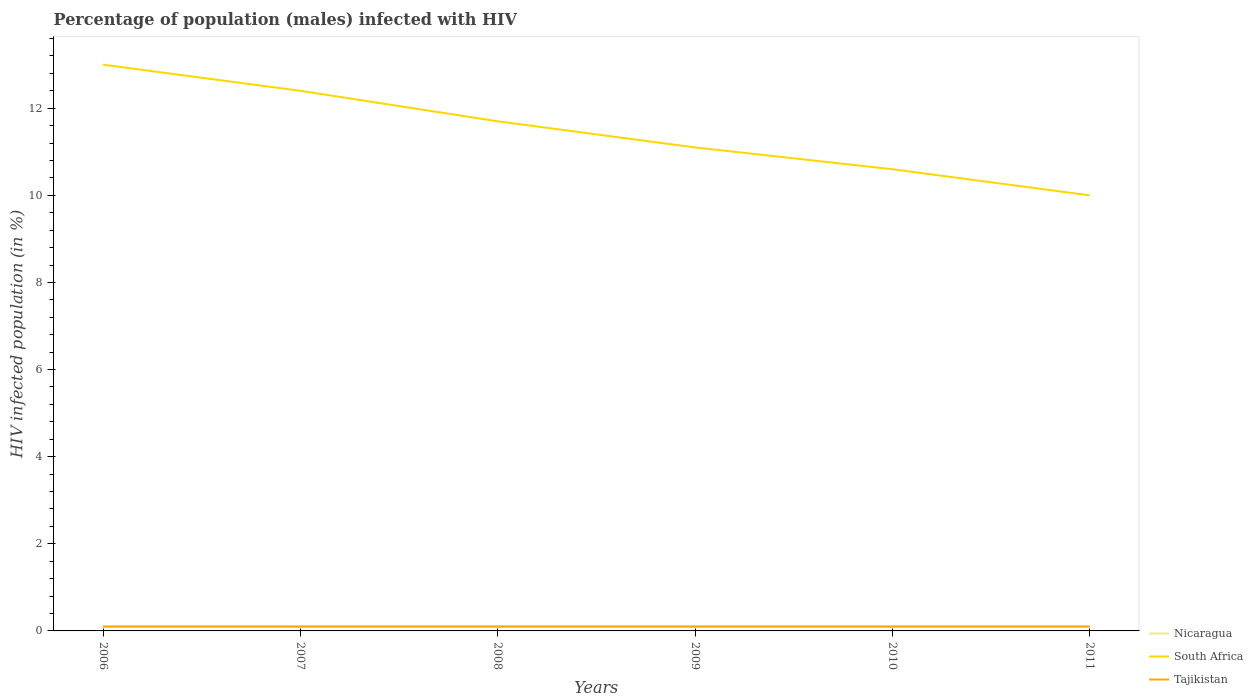How many different coloured lines are there?
Give a very brief answer. 3. In which year was the percentage of HIV infected male population in Tajikistan maximum?
Make the answer very short. 2006. What is the total percentage of HIV infected male population in South Africa in the graph?
Offer a terse response. 0.5. What is the difference between the highest and the lowest percentage of HIV infected male population in Tajikistan?
Provide a short and direct response. 6. Is the percentage of HIV infected male population in South Africa strictly greater than the percentage of HIV infected male population in Nicaragua over the years?
Provide a short and direct response. No. How many lines are there?
Ensure brevity in your answer.  3. How many years are there in the graph?
Make the answer very short. 6. Are the values on the major ticks of Y-axis written in scientific E-notation?
Ensure brevity in your answer.  No. Does the graph contain grids?
Make the answer very short. No. How are the legend labels stacked?
Offer a very short reply. Vertical. What is the title of the graph?
Ensure brevity in your answer.  Percentage of population (males) infected with HIV. What is the label or title of the X-axis?
Your answer should be compact. Years. What is the label or title of the Y-axis?
Make the answer very short. HIV infected population (in %). What is the HIV infected population (in %) in Nicaragua in 2006?
Keep it short and to the point. 0.1. What is the HIV infected population (in %) of South Africa in 2006?
Provide a short and direct response. 13. What is the HIV infected population (in %) of Tajikistan in 2006?
Make the answer very short. 0.1. What is the HIV infected population (in %) of Nicaragua in 2007?
Give a very brief answer. 0.1. What is the HIV infected population (in %) in South Africa in 2008?
Provide a succinct answer. 11.7. What is the HIV infected population (in %) of Tajikistan in 2009?
Keep it short and to the point. 0.1. What is the HIV infected population (in %) of Nicaragua in 2010?
Offer a terse response. 0.1. What is the HIV infected population (in %) in South Africa in 2010?
Give a very brief answer. 10.6. What is the HIV infected population (in %) in South Africa in 2011?
Your answer should be very brief. 10. Across all years, what is the maximum HIV infected population (in %) in South Africa?
Your answer should be very brief. 13. Across all years, what is the maximum HIV infected population (in %) of Tajikistan?
Provide a succinct answer. 0.1. Across all years, what is the minimum HIV infected population (in %) in Nicaragua?
Your response must be concise. 0.1. Across all years, what is the minimum HIV infected population (in %) of South Africa?
Offer a terse response. 10. What is the total HIV infected population (in %) of Nicaragua in the graph?
Give a very brief answer. 0.6. What is the total HIV infected population (in %) of South Africa in the graph?
Provide a short and direct response. 68.8. What is the difference between the HIV infected population (in %) of South Africa in 2006 and that in 2008?
Make the answer very short. 1.3. What is the difference between the HIV infected population (in %) in Nicaragua in 2006 and that in 2009?
Ensure brevity in your answer.  0. What is the difference between the HIV infected population (in %) in South Africa in 2006 and that in 2009?
Your answer should be very brief. 1.9. What is the difference between the HIV infected population (in %) in Tajikistan in 2006 and that in 2009?
Keep it short and to the point. 0. What is the difference between the HIV infected population (in %) of South Africa in 2006 and that in 2010?
Provide a succinct answer. 2.4. What is the difference between the HIV infected population (in %) of Tajikistan in 2006 and that in 2010?
Your answer should be very brief. 0. What is the difference between the HIV infected population (in %) in Nicaragua in 2006 and that in 2011?
Your answer should be very brief. 0. What is the difference between the HIV infected population (in %) in South Africa in 2006 and that in 2011?
Your response must be concise. 3. What is the difference between the HIV infected population (in %) of Tajikistan in 2006 and that in 2011?
Provide a short and direct response. 0. What is the difference between the HIV infected population (in %) of South Africa in 2007 and that in 2008?
Offer a terse response. 0.7. What is the difference between the HIV infected population (in %) in South Africa in 2007 and that in 2009?
Your answer should be compact. 1.3. What is the difference between the HIV infected population (in %) in Nicaragua in 2007 and that in 2010?
Provide a succinct answer. 0. What is the difference between the HIV infected population (in %) in South Africa in 2007 and that in 2010?
Offer a terse response. 1.8. What is the difference between the HIV infected population (in %) in Nicaragua in 2007 and that in 2011?
Keep it short and to the point. 0. What is the difference between the HIV infected population (in %) in South Africa in 2007 and that in 2011?
Your response must be concise. 2.4. What is the difference between the HIV infected population (in %) of Tajikistan in 2007 and that in 2011?
Offer a very short reply. 0. What is the difference between the HIV infected population (in %) of Nicaragua in 2008 and that in 2009?
Make the answer very short. 0. What is the difference between the HIV infected population (in %) of Tajikistan in 2008 and that in 2009?
Provide a succinct answer. 0. What is the difference between the HIV infected population (in %) of South Africa in 2008 and that in 2010?
Your response must be concise. 1.1. What is the difference between the HIV infected population (in %) in Nicaragua in 2008 and that in 2011?
Give a very brief answer. 0. What is the difference between the HIV infected population (in %) in South Africa in 2008 and that in 2011?
Your answer should be compact. 1.7. What is the difference between the HIV infected population (in %) of South Africa in 2009 and that in 2010?
Provide a succinct answer. 0.5. What is the difference between the HIV infected population (in %) in Nicaragua in 2009 and that in 2011?
Keep it short and to the point. 0. What is the difference between the HIV infected population (in %) in Tajikistan in 2009 and that in 2011?
Provide a short and direct response. 0. What is the difference between the HIV infected population (in %) of Nicaragua in 2010 and that in 2011?
Provide a short and direct response. 0. What is the difference between the HIV infected population (in %) of South Africa in 2010 and that in 2011?
Keep it short and to the point. 0.6. What is the difference between the HIV infected population (in %) of Nicaragua in 2006 and the HIV infected population (in %) of Tajikistan in 2007?
Offer a terse response. 0. What is the difference between the HIV infected population (in %) in South Africa in 2006 and the HIV infected population (in %) in Tajikistan in 2008?
Offer a terse response. 12.9. What is the difference between the HIV infected population (in %) of Nicaragua in 2006 and the HIV infected population (in %) of Tajikistan in 2009?
Offer a very short reply. 0. What is the difference between the HIV infected population (in %) in Nicaragua in 2006 and the HIV infected population (in %) in Tajikistan in 2010?
Provide a succinct answer. 0. What is the difference between the HIV infected population (in %) of South Africa in 2006 and the HIV infected population (in %) of Tajikistan in 2010?
Your response must be concise. 12.9. What is the difference between the HIV infected population (in %) in Nicaragua in 2007 and the HIV infected population (in %) in South Africa in 2008?
Offer a terse response. -11.6. What is the difference between the HIV infected population (in %) in Nicaragua in 2007 and the HIV infected population (in %) in Tajikistan in 2009?
Keep it short and to the point. 0. What is the difference between the HIV infected population (in %) in South Africa in 2007 and the HIV infected population (in %) in Tajikistan in 2009?
Offer a very short reply. 12.3. What is the difference between the HIV infected population (in %) of Nicaragua in 2007 and the HIV infected population (in %) of South Africa in 2010?
Offer a very short reply. -10.5. What is the difference between the HIV infected population (in %) in South Africa in 2007 and the HIV infected population (in %) in Tajikistan in 2010?
Give a very brief answer. 12.3. What is the difference between the HIV infected population (in %) of Nicaragua in 2007 and the HIV infected population (in %) of South Africa in 2011?
Make the answer very short. -9.9. What is the difference between the HIV infected population (in %) of South Africa in 2008 and the HIV infected population (in %) of Tajikistan in 2009?
Provide a short and direct response. 11.6. What is the difference between the HIV infected population (in %) in Nicaragua in 2008 and the HIV infected population (in %) in South Africa in 2010?
Provide a succinct answer. -10.5. What is the difference between the HIV infected population (in %) of Nicaragua in 2008 and the HIV infected population (in %) of Tajikistan in 2010?
Offer a very short reply. 0. What is the difference between the HIV infected population (in %) of Nicaragua in 2008 and the HIV infected population (in %) of South Africa in 2011?
Your answer should be compact. -9.9. What is the difference between the HIV infected population (in %) in Nicaragua in 2009 and the HIV infected population (in %) in Tajikistan in 2010?
Ensure brevity in your answer.  0. What is the difference between the HIV infected population (in %) in Nicaragua in 2009 and the HIV infected population (in %) in Tajikistan in 2011?
Provide a succinct answer. 0. What is the difference between the HIV infected population (in %) in South Africa in 2009 and the HIV infected population (in %) in Tajikistan in 2011?
Make the answer very short. 11. What is the difference between the HIV infected population (in %) in Nicaragua in 2010 and the HIV infected population (in %) in South Africa in 2011?
Keep it short and to the point. -9.9. What is the difference between the HIV infected population (in %) of South Africa in 2010 and the HIV infected population (in %) of Tajikistan in 2011?
Offer a terse response. 10.5. What is the average HIV infected population (in %) of Nicaragua per year?
Offer a very short reply. 0.1. What is the average HIV infected population (in %) in South Africa per year?
Give a very brief answer. 11.47. In the year 2006, what is the difference between the HIV infected population (in %) in Nicaragua and HIV infected population (in %) in Tajikistan?
Ensure brevity in your answer.  0. In the year 2006, what is the difference between the HIV infected population (in %) in South Africa and HIV infected population (in %) in Tajikistan?
Your answer should be very brief. 12.9. In the year 2007, what is the difference between the HIV infected population (in %) of Nicaragua and HIV infected population (in %) of Tajikistan?
Give a very brief answer. 0. In the year 2007, what is the difference between the HIV infected population (in %) of South Africa and HIV infected population (in %) of Tajikistan?
Give a very brief answer. 12.3. In the year 2008, what is the difference between the HIV infected population (in %) of Nicaragua and HIV infected population (in %) of Tajikistan?
Make the answer very short. 0. In the year 2009, what is the difference between the HIV infected population (in %) of South Africa and HIV infected population (in %) of Tajikistan?
Offer a terse response. 11. In the year 2010, what is the difference between the HIV infected population (in %) in Nicaragua and HIV infected population (in %) in Tajikistan?
Your answer should be compact. 0. In the year 2011, what is the difference between the HIV infected population (in %) in Nicaragua and HIV infected population (in %) in Tajikistan?
Offer a terse response. 0. What is the ratio of the HIV infected population (in %) of South Africa in 2006 to that in 2007?
Provide a succinct answer. 1.05. What is the ratio of the HIV infected population (in %) in Tajikistan in 2006 to that in 2007?
Give a very brief answer. 1. What is the ratio of the HIV infected population (in %) of Nicaragua in 2006 to that in 2008?
Your answer should be very brief. 1. What is the ratio of the HIV infected population (in %) in South Africa in 2006 to that in 2008?
Your answer should be very brief. 1.11. What is the ratio of the HIV infected population (in %) in Nicaragua in 2006 to that in 2009?
Keep it short and to the point. 1. What is the ratio of the HIV infected population (in %) of South Africa in 2006 to that in 2009?
Provide a succinct answer. 1.17. What is the ratio of the HIV infected population (in %) of Tajikistan in 2006 to that in 2009?
Give a very brief answer. 1. What is the ratio of the HIV infected population (in %) in South Africa in 2006 to that in 2010?
Keep it short and to the point. 1.23. What is the ratio of the HIV infected population (in %) of Nicaragua in 2006 to that in 2011?
Give a very brief answer. 1. What is the ratio of the HIV infected population (in %) in Tajikistan in 2006 to that in 2011?
Offer a terse response. 1. What is the ratio of the HIV infected population (in %) of Nicaragua in 2007 to that in 2008?
Your answer should be compact. 1. What is the ratio of the HIV infected population (in %) in South Africa in 2007 to that in 2008?
Keep it short and to the point. 1.06. What is the ratio of the HIV infected population (in %) of Tajikistan in 2007 to that in 2008?
Give a very brief answer. 1. What is the ratio of the HIV infected population (in %) of South Africa in 2007 to that in 2009?
Offer a very short reply. 1.12. What is the ratio of the HIV infected population (in %) of Tajikistan in 2007 to that in 2009?
Make the answer very short. 1. What is the ratio of the HIV infected population (in %) of South Africa in 2007 to that in 2010?
Make the answer very short. 1.17. What is the ratio of the HIV infected population (in %) in Tajikistan in 2007 to that in 2010?
Make the answer very short. 1. What is the ratio of the HIV infected population (in %) in South Africa in 2007 to that in 2011?
Ensure brevity in your answer.  1.24. What is the ratio of the HIV infected population (in %) of Tajikistan in 2007 to that in 2011?
Offer a very short reply. 1. What is the ratio of the HIV infected population (in %) in Nicaragua in 2008 to that in 2009?
Your answer should be compact. 1. What is the ratio of the HIV infected population (in %) of South Africa in 2008 to that in 2009?
Give a very brief answer. 1.05. What is the ratio of the HIV infected population (in %) in Tajikistan in 2008 to that in 2009?
Ensure brevity in your answer.  1. What is the ratio of the HIV infected population (in %) of South Africa in 2008 to that in 2010?
Your answer should be compact. 1.1. What is the ratio of the HIV infected population (in %) in South Africa in 2008 to that in 2011?
Your answer should be compact. 1.17. What is the ratio of the HIV infected population (in %) of South Africa in 2009 to that in 2010?
Provide a short and direct response. 1.05. What is the ratio of the HIV infected population (in %) of South Africa in 2009 to that in 2011?
Offer a very short reply. 1.11. What is the ratio of the HIV infected population (in %) of Nicaragua in 2010 to that in 2011?
Provide a succinct answer. 1. What is the ratio of the HIV infected population (in %) of South Africa in 2010 to that in 2011?
Ensure brevity in your answer.  1.06. What is the ratio of the HIV infected population (in %) in Tajikistan in 2010 to that in 2011?
Provide a succinct answer. 1. What is the difference between the highest and the second highest HIV infected population (in %) of South Africa?
Make the answer very short. 0.6. What is the difference between the highest and the lowest HIV infected population (in %) in Nicaragua?
Give a very brief answer. 0. What is the difference between the highest and the lowest HIV infected population (in %) of South Africa?
Offer a terse response. 3. What is the difference between the highest and the lowest HIV infected population (in %) in Tajikistan?
Keep it short and to the point. 0. 